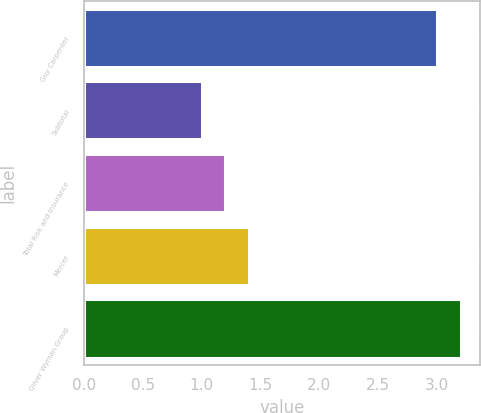Convert chart to OTSL. <chart><loc_0><loc_0><loc_500><loc_500><bar_chart><fcel>Guy Carpenter<fcel>Subtotal<fcel>Total Risk and Insurance<fcel>Mercer<fcel>Oliver Wyman Group<nl><fcel>3<fcel>1<fcel>1.2<fcel>1.4<fcel>3.2<nl></chart> 